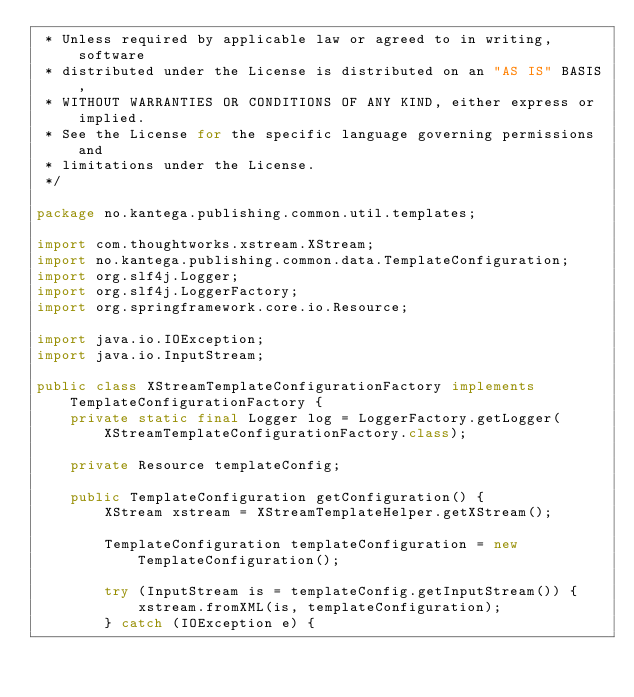<code> <loc_0><loc_0><loc_500><loc_500><_Java_> * Unless required by applicable law or agreed to in writing, software
 * distributed under the License is distributed on an "AS IS" BASIS,
 * WITHOUT WARRANTIES OR CONDITIONS OF ANY KIND, either express or implied.
 * See the License for the specific language governing permissions and
 * limitations under the License.
 */

package no.kantega.publishing.common.util.templates;

import com.thoughtworks.xstream.XStream;
import no.kantega.publishing.common.data.TemplateConfiguration;
import org.slf4j.Logger;
import org.slf4j.LoggerFactory;
import org.springframework.core.io.Resource;

import java.io.IOException;
import java.io.InputStream;

public class XStreamTemplateConfigurationFactory implements TemplateConfigurationFactory {
    private static final Logger log = LoggerFactory.getLogger(XStreamTemplateConfigurationFactory.class);

    private Resource templateConfig;

    public TemplateConfiguration getConfiguration() {
        XStream xstream = XStreamTemplateHelper.getXStream();

        TemplateConfiguration templateConfiguration = new TemplateConfiguration();

        try (InputStream is = templateConfig.getInputStream()) {
            xstream.fromXML(is, templateConfiguration);
        } catch (IOException e) {</code> 